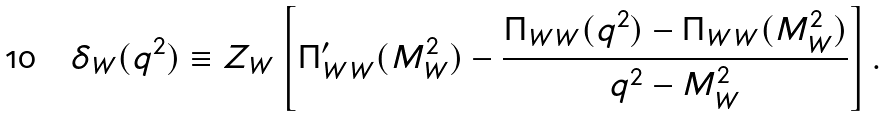Convert formula to latex. <formula><loc_0><loc_0><loc_500><loc_500>\delta _ { W } ( q ^ { 2 } ) \equiv Z _ { W } \left [ \Pi _ { W W } ^ { \prime } ( M _ { W } ^ { 2 } ) - \frac { \Pi _ { W W } ( q ^ { 2 } ) - \Pi _ { W W } ( M _ { W } ^ { 2 } ) } { q ^ { 2 } - M _ { W } ^ { 2 } } \right ] .</formula> 